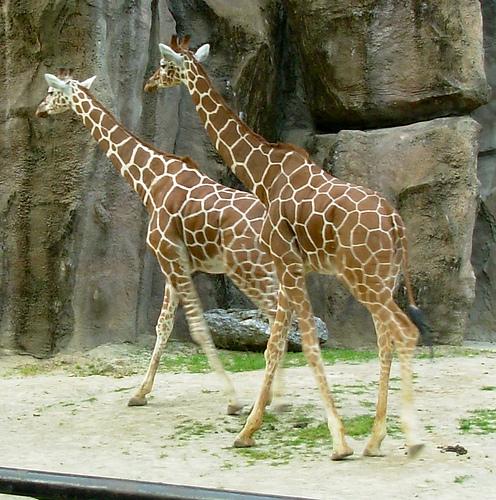Are both of these animals adults?
Short answer required. Yes. How many Giraffes are in the picture?
Write a very short answer. 2. What kind of enclosure is this?
Be succinct. Zoo. How many horns can you see?
Write a very short answer. 4. How many giraffes are there?
Write a very short answer. 2. Why is the big giraffe smelling the small one?
Answer briefly. It's not. What animals are in the enclosure?
Answer briefly. Giraffes. 